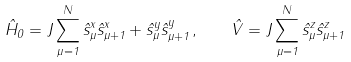<formula> <loc_0><loc_0><loc_500><loc_500>\hat { H } _ { 0 } = J \sum _ { \mu = 1 } ^ { N } \hat { s } _ { \mu } ^ { x } \hat { s } _ { \mu + 1 } ^ { x } + \hat { s } _ { \mu } ^ { y } \hat { s } _ { \mu + 1 } ^ { y } \, , \quad \hat { V } = J \sum _ { \mu = 1 } ^ { N } \hat { s } _ { \mu } ^ { z } \hat { s } _ { \mu + 1 } ^ { z }</formula> 